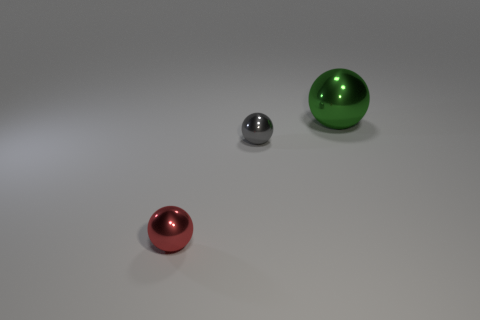Subtract all gray metal spheres. How many spheres are left? 2 Add 2 big green matte things. How many objects exist? 5 Subtract all red spheres. How many spheres are left? 2 Subtract 2 spheres. How many spheres are left? 1 Subtract all blue balls. Subtract all gray cylinders. How many balls are left? 3 Add 3 green shiny objects. How many green shiny objects are left? 4 Add 1 small gray spheres. How many small gray spheres exist? 2 Subtract 1 red balls. How many objects are left? 2 Subtract all red metal objects. Subtract all small balls. How many objects are left? 0 